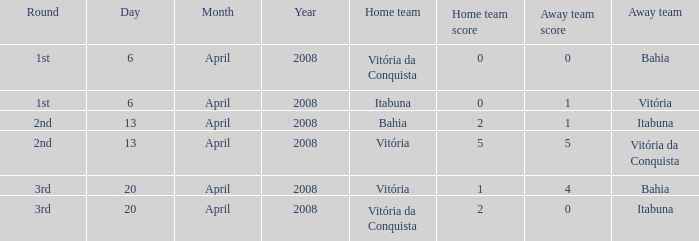When vitória was the visiting team, who was the host team? Itabuna. 